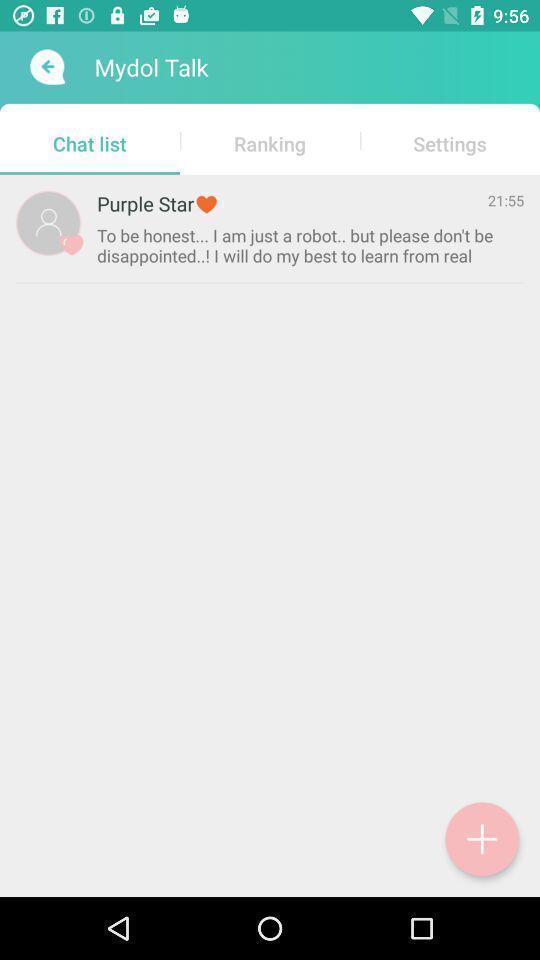Tell me about the visual elements in this screen capture. Screen showing chat list. 